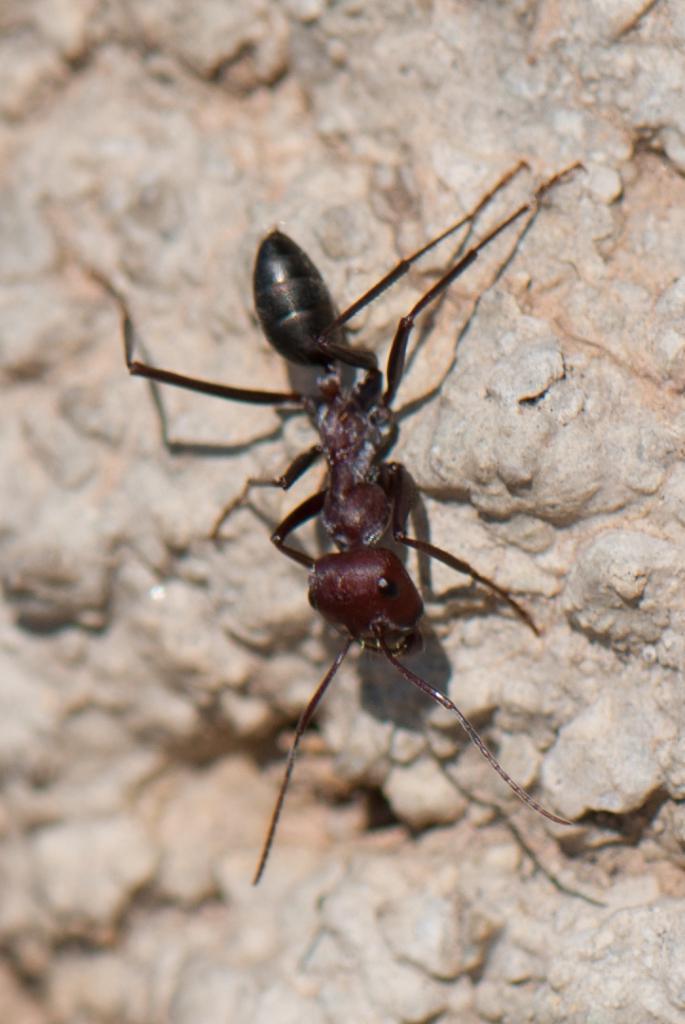Could you give a brief overview of what you see in this image? In this picture, we see an ant which is black in color. In the background, we see the rock or a wall which is made up of stones. This picture is blurred in the background. 